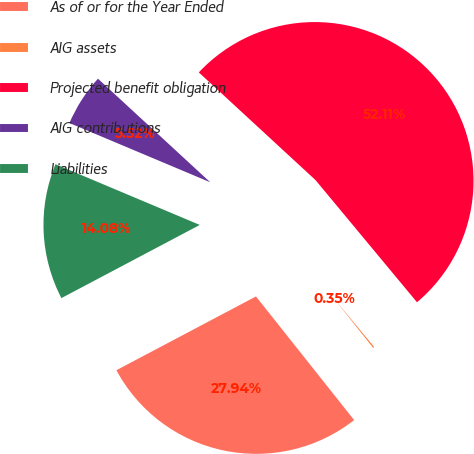Convert chart. <chart><loc_0><loc_0><loc_500><loc_500><pie_chart><fcel>As of or for the Year Ended<fcel>AIG assets<fcel>Projected benefit obligation<fcel>AIG contributions<fcel>Liabilities<nl><fcel>27.94%<fcel>0.35%<fcel>52.11%<fcel>5.52%<fcel>14.08%<nl></chart> 